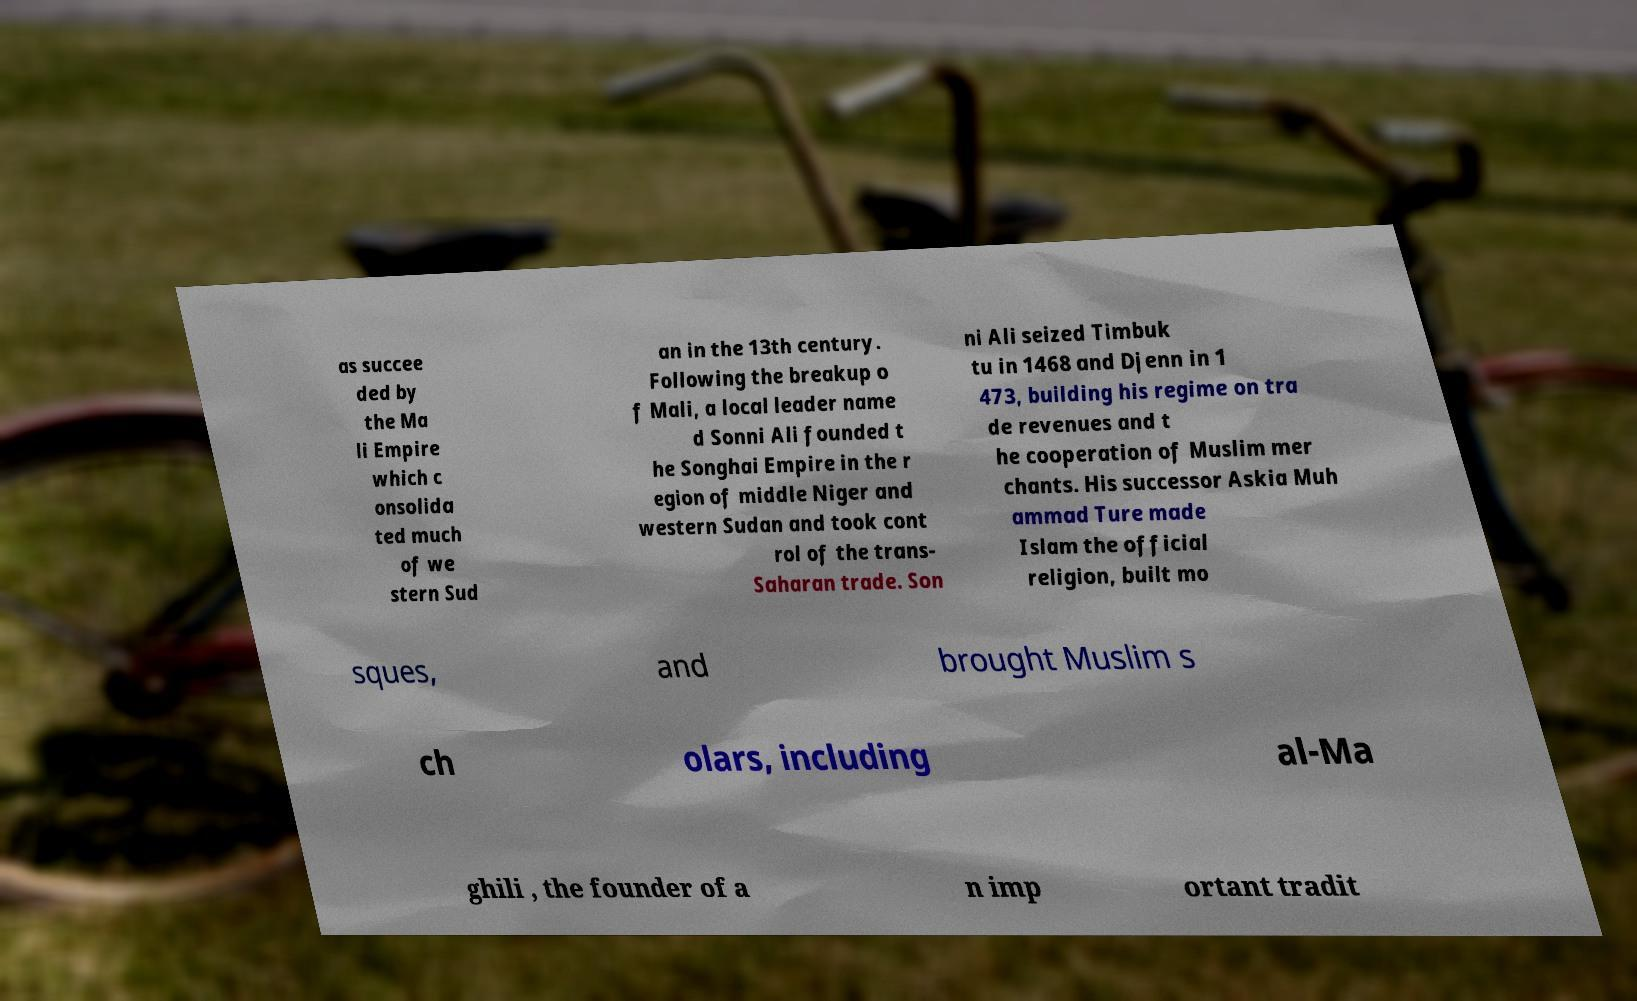Please identify and transcribe the text found in this image. as succee ded by the Ma li Empire which c onsolida ted much of we stern Sud an in the 13th century. Following the breakup o f Mali, a local leader name d Sonni Ali founded t he Songhai Empire in the r egion of middle Niger and western Sudan and took cont rol of the trans- Saharan trade. Son ni Ali seized Timbuk tu in 1468 and Djenn in 1 473, building his regime on tra de revenues and t he cooperation of Muslim mer chants. His successor Askia Muh ammad Ture made Islam the official religion, built mo sques, and brought Muslim s ch olars, including al-Ma ghili , the founder of a n imp ortant tradit 